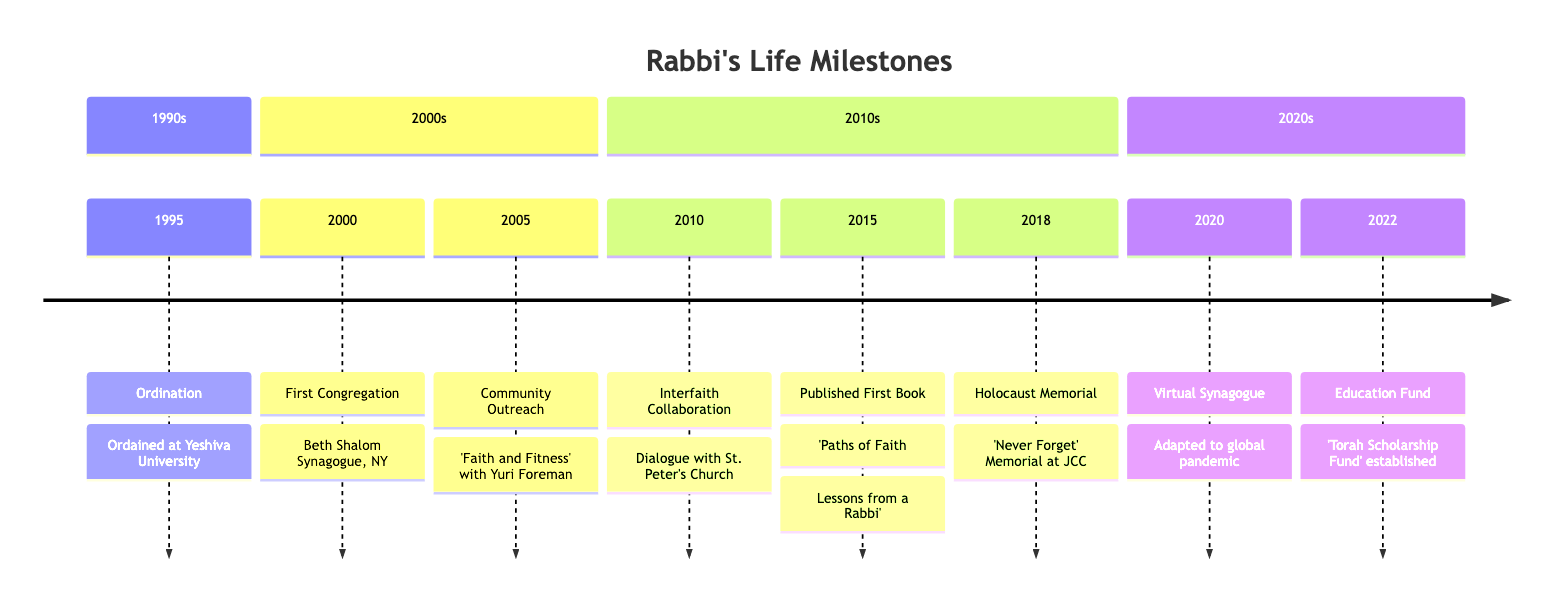What year was the Rabbi ordained? The diagram indicates that the ordination event took place in 1995. This is explicitly stated as the first milestone in the timeline.
Answer: 1995 Which synagogues are mentioned in the timeline? The timeline references the Beth Shalom Synagogue where the Rabbi started serving in 2000. This is the only synagogue mentioned in the events.
Answer: Beth Shalom Synagogue What significant event took place in 2018? The timeline highlights that in 2018, the Rabbi led the creation of the 'Never Forget' Holocaust Memorial, marking it as a significant community contribution.
Answer: Holocaust Memorial Initiative How many years passed between the establishment of the Torah Scholarship Fund and the launch of the virtual synagogue? To find the difference, look at the years: the virtual synagogue was launched in 2020 and the Torah Scholarship Fund was established in 2022. So, 2022 - 2020 = 2 years.
Answer: 2 years What was the Rabbi's contribution to interfaith dialogue? According to the timeline, in 2010, the Rabbi initiated a dialogue series with St. Peter's Church aimed at fostering understanding among different faith communities.
Answer: Initiated interfaith dialogue series Which event occurred first: the publication of the first book or the Holocaust Memorial initiative? By examining the timeline, it's clear that the publication of 'Paths of Faith: Lessons from a Rabbi' occurred in 2015 and the Holocaust Memorial initiative took place in 2018, making the book publication the earlier event.
Answer: Published First Book How many community initiatives are listed in the timeline? The timeline outlines three community-related initiatives: the 'Faith and Fitness' program in 2005, the interfaith dialogue series in 2010, and the Holocaust Memorial in 2018. By counting these events, we find there are three distinct initiatives shown.
Answer: 3 What is the title of the first book published by the Rabbi? The timeline indicates that the Rabbi published 'Paths of Faith: Lessons from a Rabbi' in 2015 as their first book, which directly answers the query about the title.
Answer: Paths of Faith: Lessons from a Rabbi In what year did the Rabbi start at the Beth Shalom Synagogue? The timeline states that the Rabbi started serving at the Beth Shalom Synagogue in 2000, which directly answers the question about the specific year.
Answer: 2000 